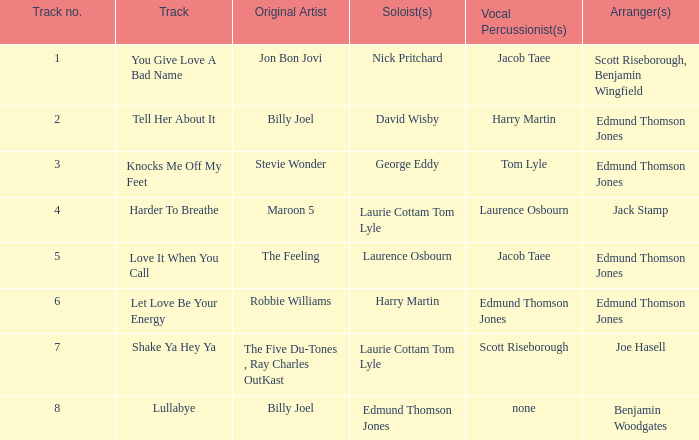With whom did tom lyle work on arranging songs that included vocal percussion? Edmund Thomson Jones. 